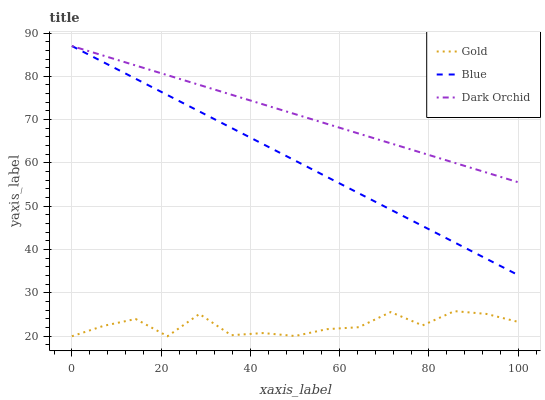Does Gold have the minimum area under the curve?
Answer yes or no. Yes. Does Dark Orchid have the maximum area under the curve?
Answer yes or no. Yes. Does Dark Orchid have the minimum area under the curve?
Answer yes or no. No. Does Gold have the maximum area under the curve?
Answer yes or no. No. Is Dark Orchid the smoothest?
Answer yes or no. Yes. Is Gold the roughest?
Answer yes or no. Yes. Is Gold the smoothest?
Answer yes or no. No. Is Dark Orchid the roughest?
Answer yes or no. No. Does Gold have the lowest value?
Answer yes or no. Yes. Does Dark Orchid have the lowest value?
Answer yes or no. No. Does Dark Orchid have the highest value?
Answer yes or no. Yes. Does Gold have the highest value?
Answer yes or no. No. Is Gold less than Dark Orchid?
Answer yes or no. Yes. Is Dark Orchid greater than Gold?
Answer yes or no. Yes. Does Dark Orchid intersect Blue?
Answer yes or no. Yes. Is Dark Orchid less than Blue?
Answer yes or no. No. Is Dark Orchid greater than Blue?
Answer yes or no. No. Does Gold intersect Dark Orchid?
Answer yes or no. No. 